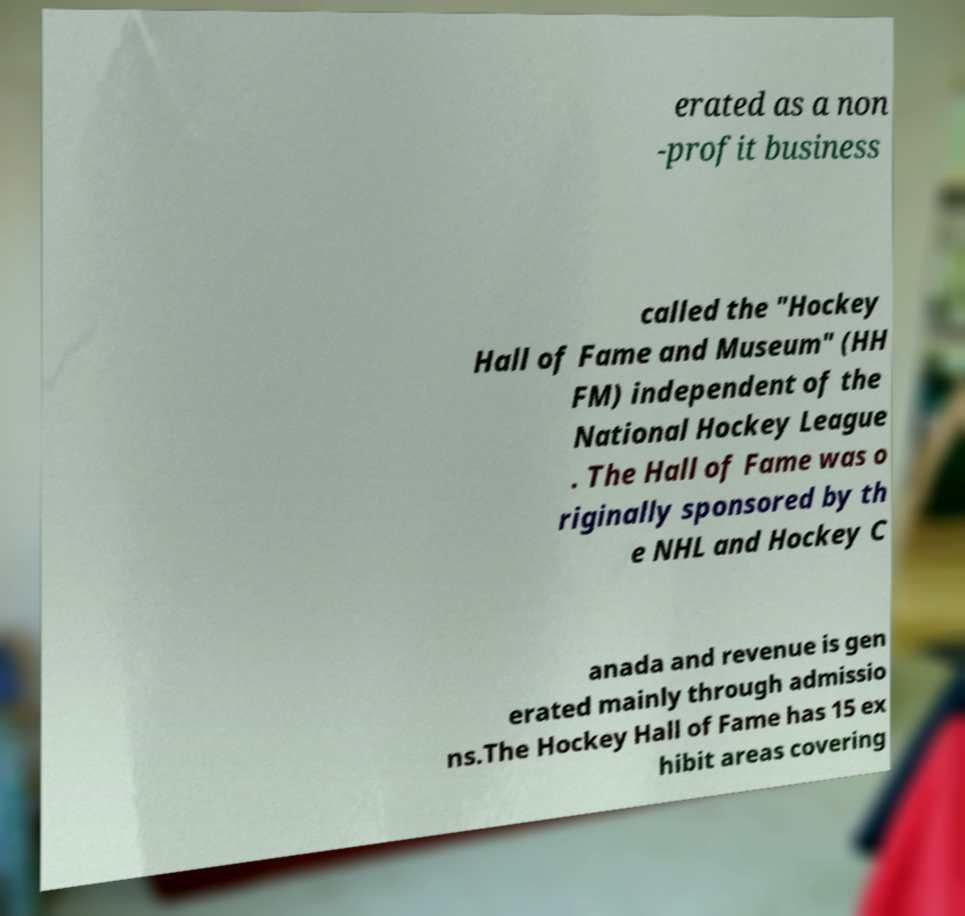Can you read and provide the text displayed in the image?This photo seems to have some interesting text. Can you extract and type it out for me? erated as a non -profit business called the "Hockey Hall of Fame and Museum" (HH FM) independent of the National Hockey League . The Hall of Fame was o riginally sponsored by th e NHL and Hockey C anada and revenue is gen erated mainly through admissio ns.The Hockey Hall of Fame has 15 ex hibit areas covering 